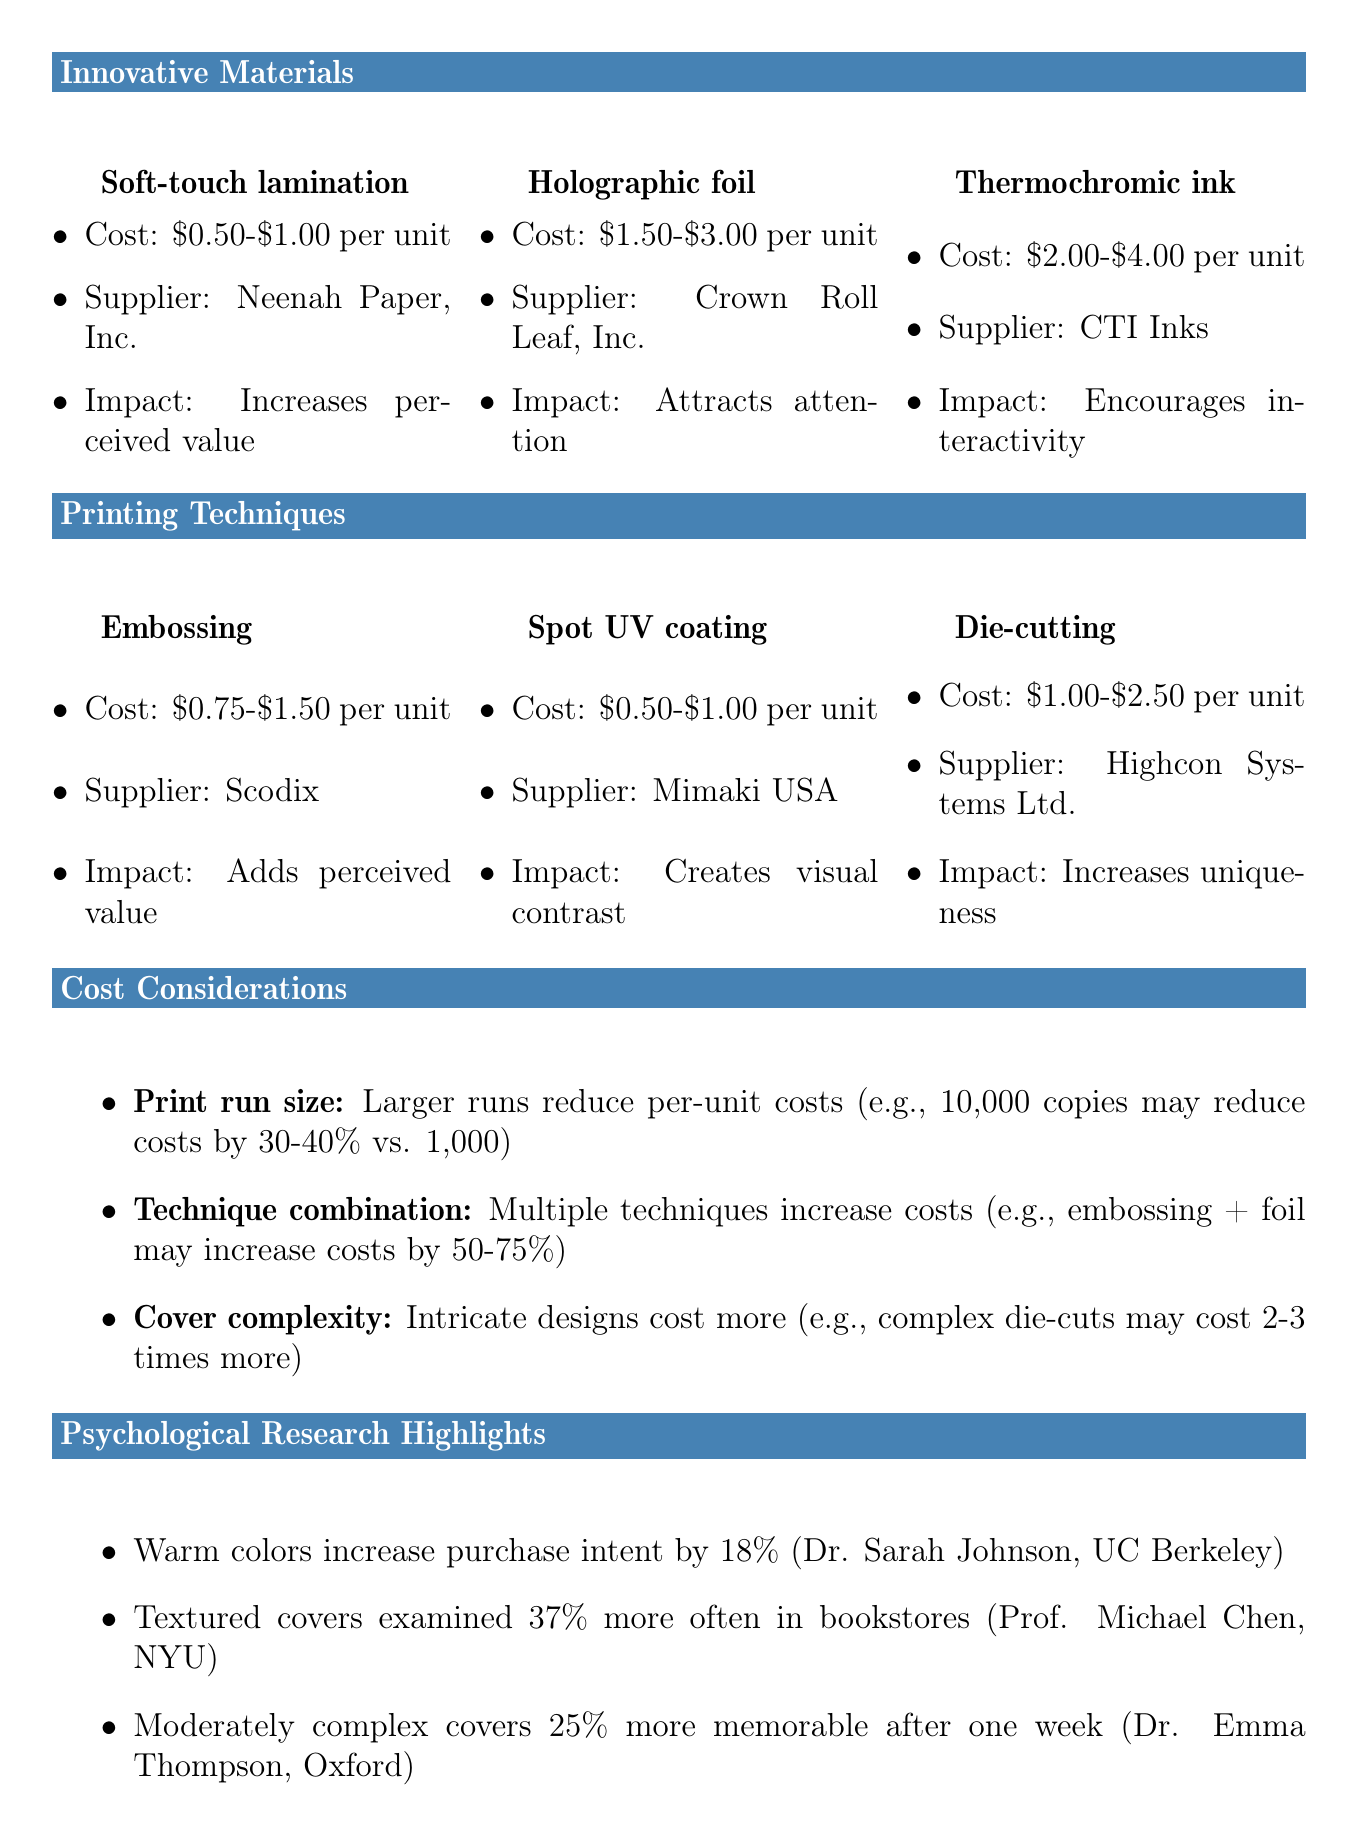What is the cost range for Soft-touch lamination? The cost range for Soft-touch lamination is listed as $0.50-$1.00 per unit.
Answer: $0.50-$1.00 Who is the supplier for Holographic foil? The supplier for Holographic foil is mentioned as Crown Roll Leaf, Inc.
Answer: Crown Roll Leaf, Inc What psychological impact does Thermochromic ink have? The psychological impact of Thermochromic ink is that it encourages interactivity and creates a sense of mystery.
Answer: Encourages interactivity and creates a sense of mystery How much can larger print runs reduce per-unit costs? The document states that larger print runs can reduce per-unit costs by 30-40% compared to smaller runs like 1,000 copies.
Answer: 30-40% Which printing technique creates visual contrast? Spot UV coating is the technique that applies a glossy finish to selected areas, creating visual contrast.
Answer: Spot UV coating What trend involves the increasing use of recycled materials? The trend related to the increasing use of recycled materials is sustainability in materials.
Answer: Sustainability What is the key finding in Dr. Sarah Johnson's study? The key finding in Dr. Sarah Johnson's study is that warm colors increased purchase intent by 18%.
Answer: Increased purchase intent by 18% How many times more memorable were moderately complex covers compared to simple or highly complex ones? Moderately complex book covers were remembered 25% more accurately than others after a one-week delay.
Answer: 25% more 